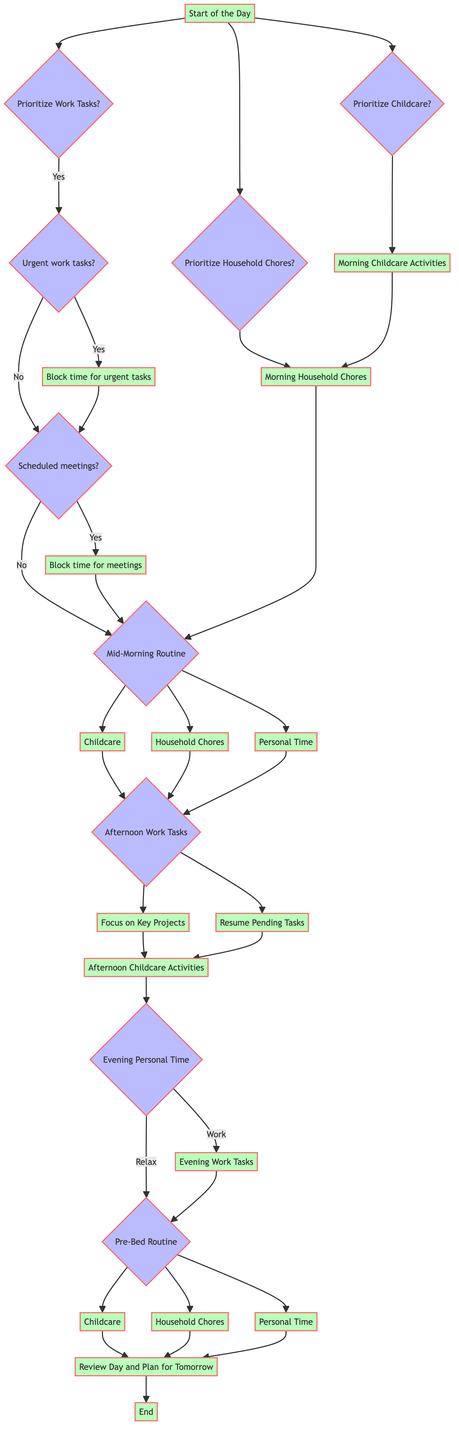What is the first decision point in the diagram? The first decision point in the diagram is labeled "Start of the Day." It is the beginning node from which all other decisions stem.
Answer: Start of the Day How many choices are there at the "Start of the Day"? At the "Start of the Day," there are three choices available: Prioritize Work Tasks, Prioritize Household Chores, and Prioritize Childcare. These choices lead to different paths in the decision tree.
Answer: Three What happens if there are urgent work tasks? If urgent work tasks are present, the flow moves to "Block time for urgent tasks," indicating that time needs to be allocated for these tasks before proceeding further in the schedule.
Answer: Block time for urgent tasks What node follows after completing "Afternoon Work Tasks"? After completing "Afternoon Work Tasks," the decision tree leads to the node that covers "Afternoon Childcare Activities," suggesting that childcare responsibilities come next after finishing work tasks.
Answer: Afternoon Childcare Activities If "Mid-Morning Routine" includes Personal Time, what is the next possible node? If "Mid-Morning Routine" includes Personal Time, the next possible node reached after finishing that Personal Time is "Afternoon Work Tasks," indicating a transition back to work-focused activities.
Answer: Afternoon Work Tasks What are the options available during "Evening Personal Time"? During "Evening Personal Time," there are two options available: Relax and Unwind, or Continue Work Tasks. These options determine the following action in the evening schedule.
Answer: Relax and Unwind, Continue Work Tasks How many nodes lead to "Review Day and Plan for Tomorrow"? There are three nodes that lead to "Review Day and Plan for Tomorrow": Childcare, Household Chores, and Personal Time, each representing an end-of-day activity before wrapping up the day.
Answer: Three What choice is made if a person chooses to prioritize Household Chores at the start of the day? If Household Chores are prioritized at the start of the day, the flow leads directly to "Morning Household Chores," where the next tasks are addressed.
Answer: Morning Household Chores 